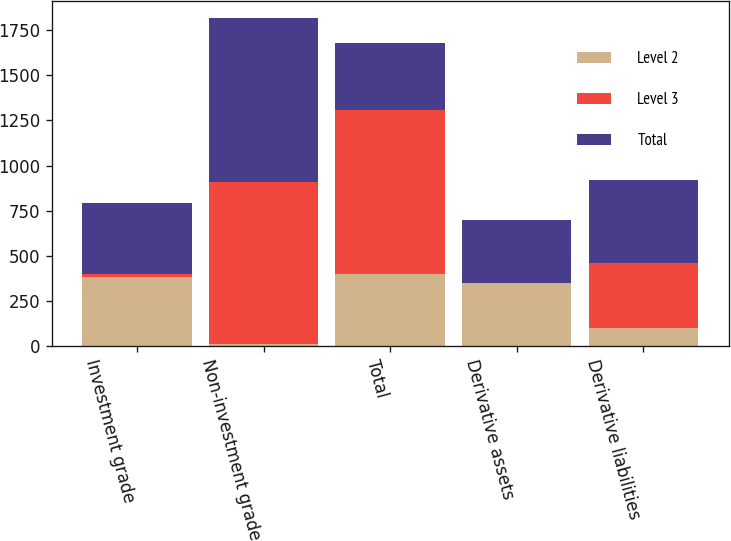<chart> <loc_0><loc_0><loc_500><loc_500><stacked_bar_chart><ecel><fcel>Investment grade<fcel>Non-investment grade<fcel>Total<fcel>Derivative assets<fcel>Derivative liabilities<nl><fcel>Level 2<fcel>385<fcel>14<fcel>399<fcel>348<fcel>98<nl><fcel>Level 3<fcel>12<fcel>895<fcel>907<fcel>2<fcel>361<nl><fcel>Total<fcel>397<fcel>909<fcel>373<fcel>350<fcel>459<nl></chart> 